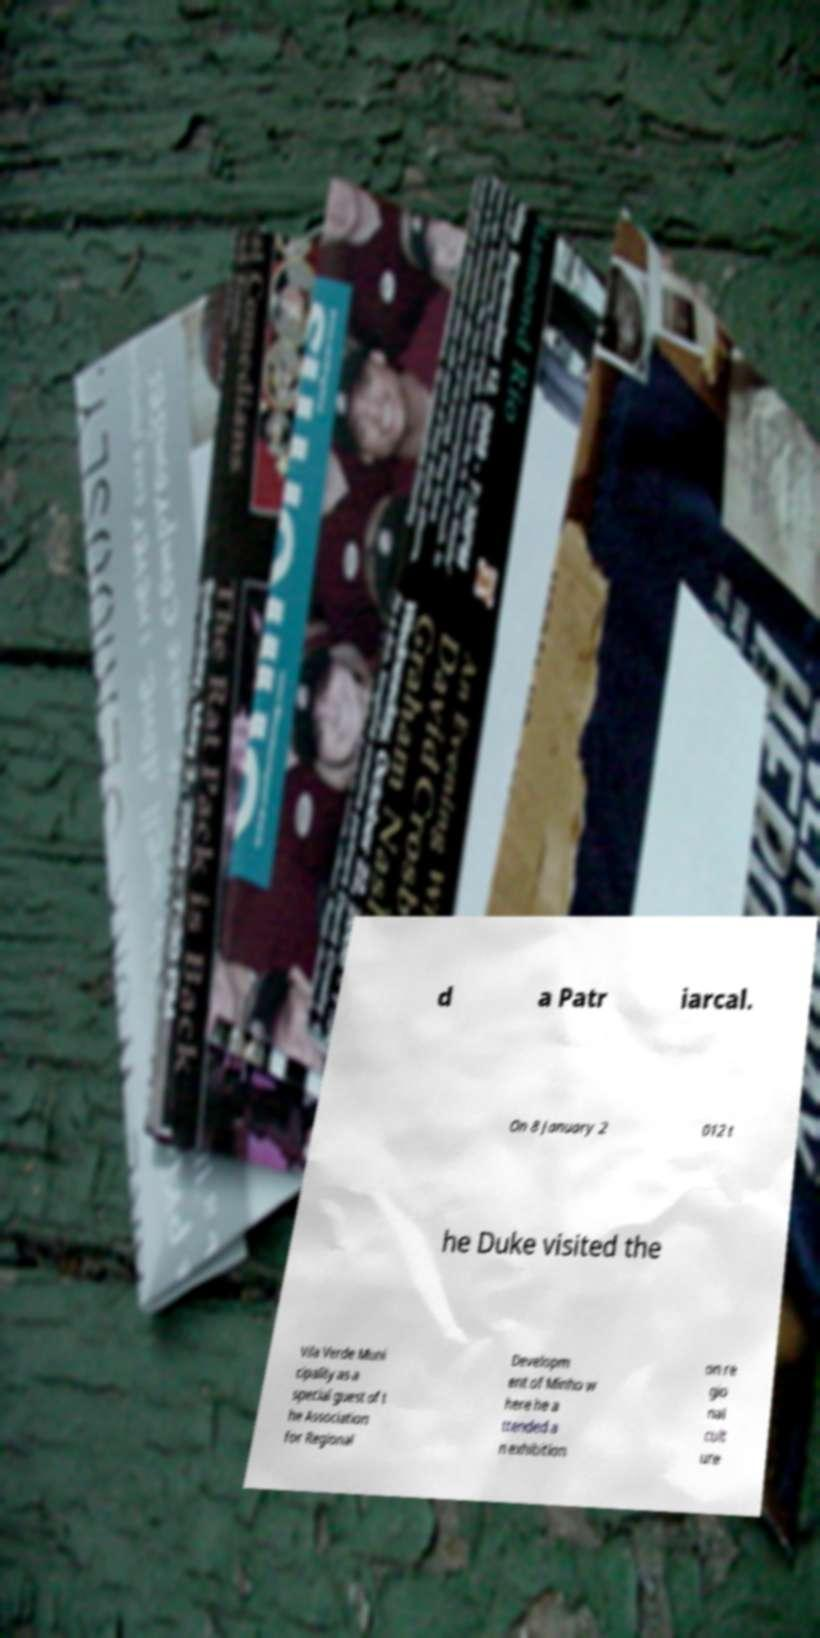Can you accurately transcribe the text from the provided image for me? d a Patr iarcal. On 8 January 2 012 t he Duke visited the Vila Verde Muni cipality as a special guest of t he Association for Regional Developm ent of Minho w here he a ttended a n exhibition on re gio nal cult ure 